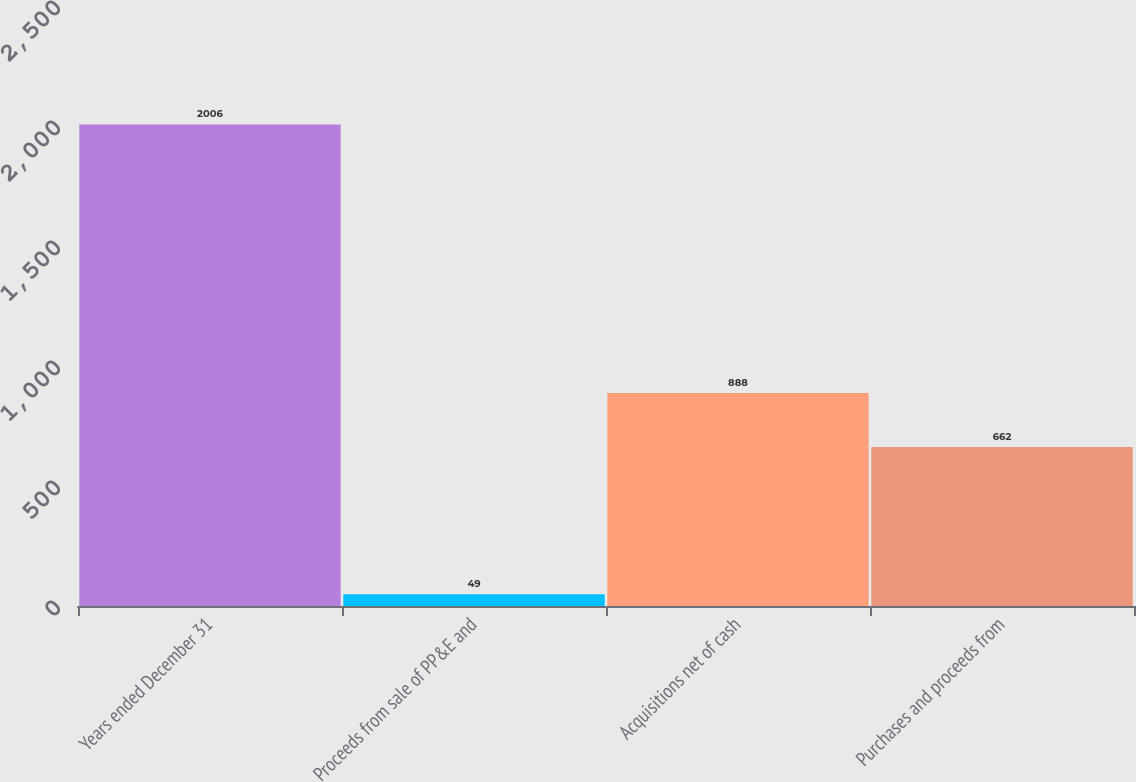Convert chart to OTSL. <chart><loc_0><loc_0><loc_500><loc_500><bar_chart><fcel>Years ended December 31<fcel>Proceeds from sale of PP&E and<fcel>Acquisitions net of cash<fcel>Purchases and proceeds from<nl><fcel>2006<fcel>49<fcel>888<fcel>662<nl></chart> 